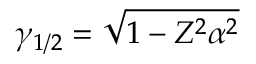<formula> <loc_0><loc_0><loc_500><loc_500>\gamma _ { 1 / 2 } = \sqrt { 1 - Z ^ { 2 } \alpha ^ { 2 } }</formula> 